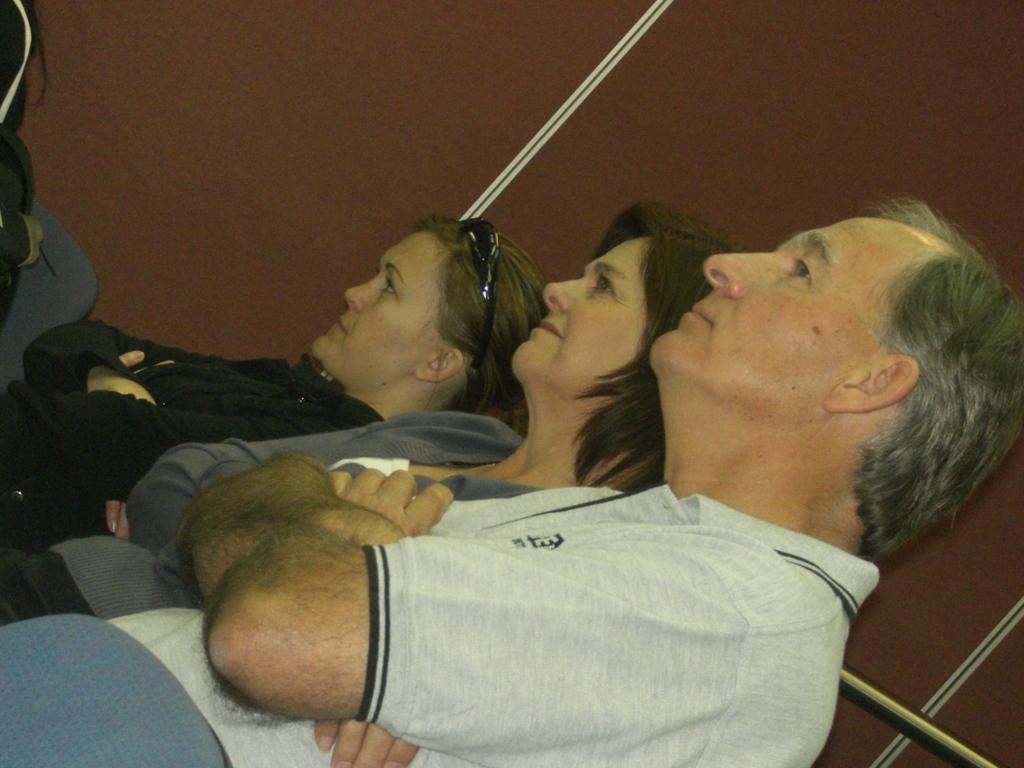Please provide a concise description of this image. In this image there are three persons who are sitting in the chairs one beside the other. In the background there is a wall. There is a man on the right side and two women beside him. All the three persons are holding their hands. 